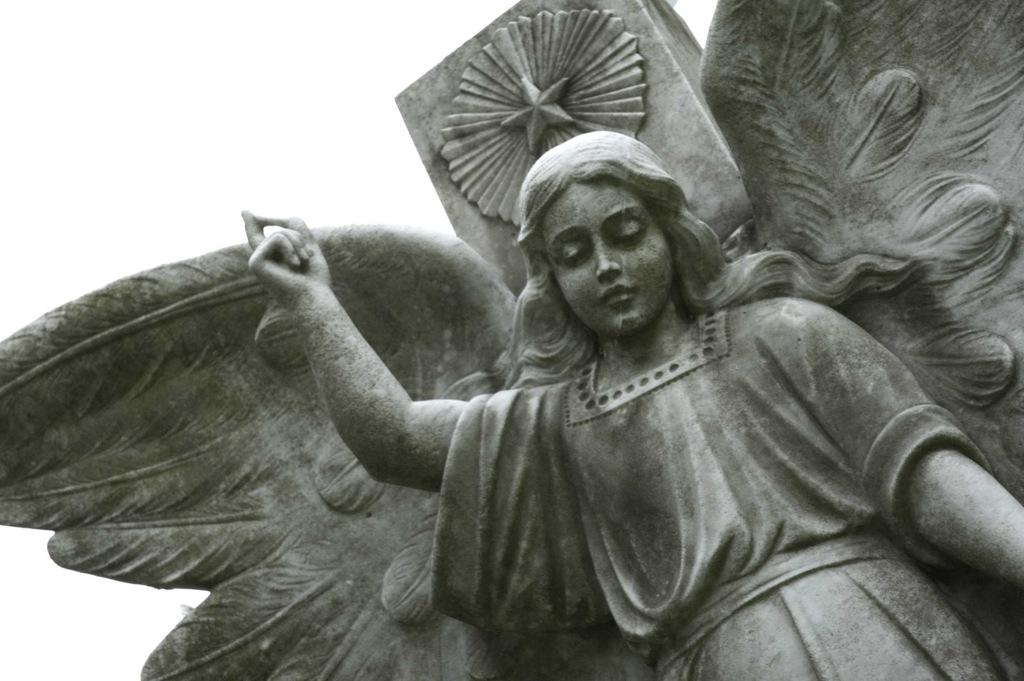What is the main subject in the foreground of the image? There is a sculpture in the foreground of the image. What can be seen in the background of the image? The sky is visible at the top of the image. Who gave their approval for the sculpture in the image? There is no information about who approved the sculpture in the image. Who is the owner of the sculpture in the image? There is no information about the owner of the sculpture in the image. 